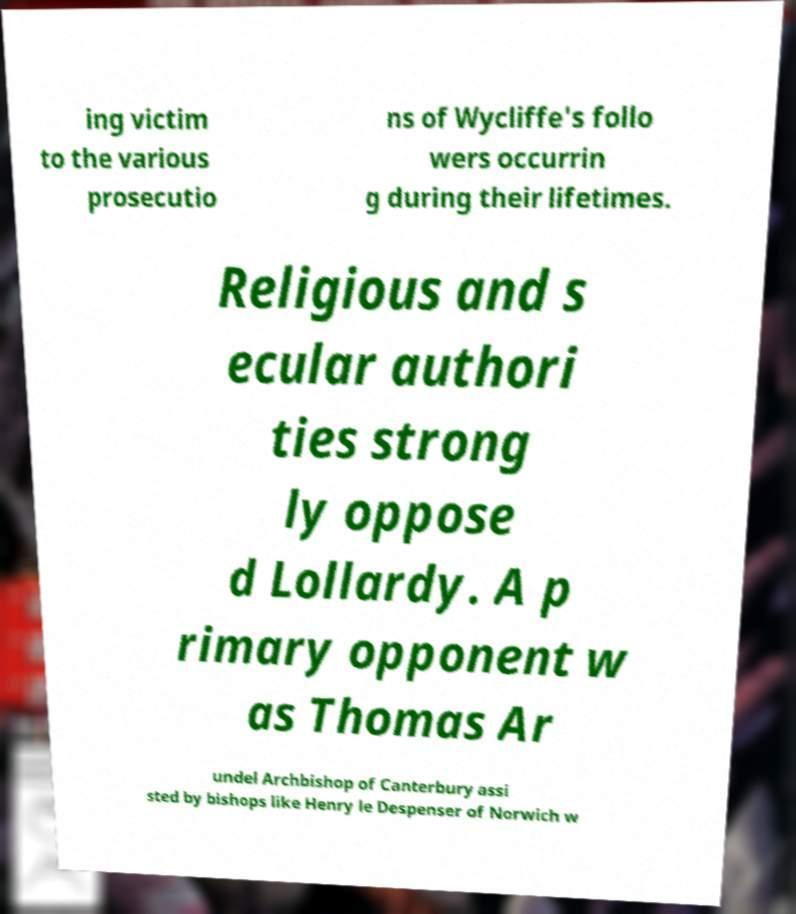Please identify and transcribe the text found in this image. ing victim to the various prosecutio ns of Wycliffe's follo wers occurrin g during their lifetimes. Religious and s ecular authori ties strong ly oppose d Lollardy. A p rimary opponent w as Thomas Ar undel Archbishop of Canterbury assi sted by bishops like Henry le Despenser of Norwich w 